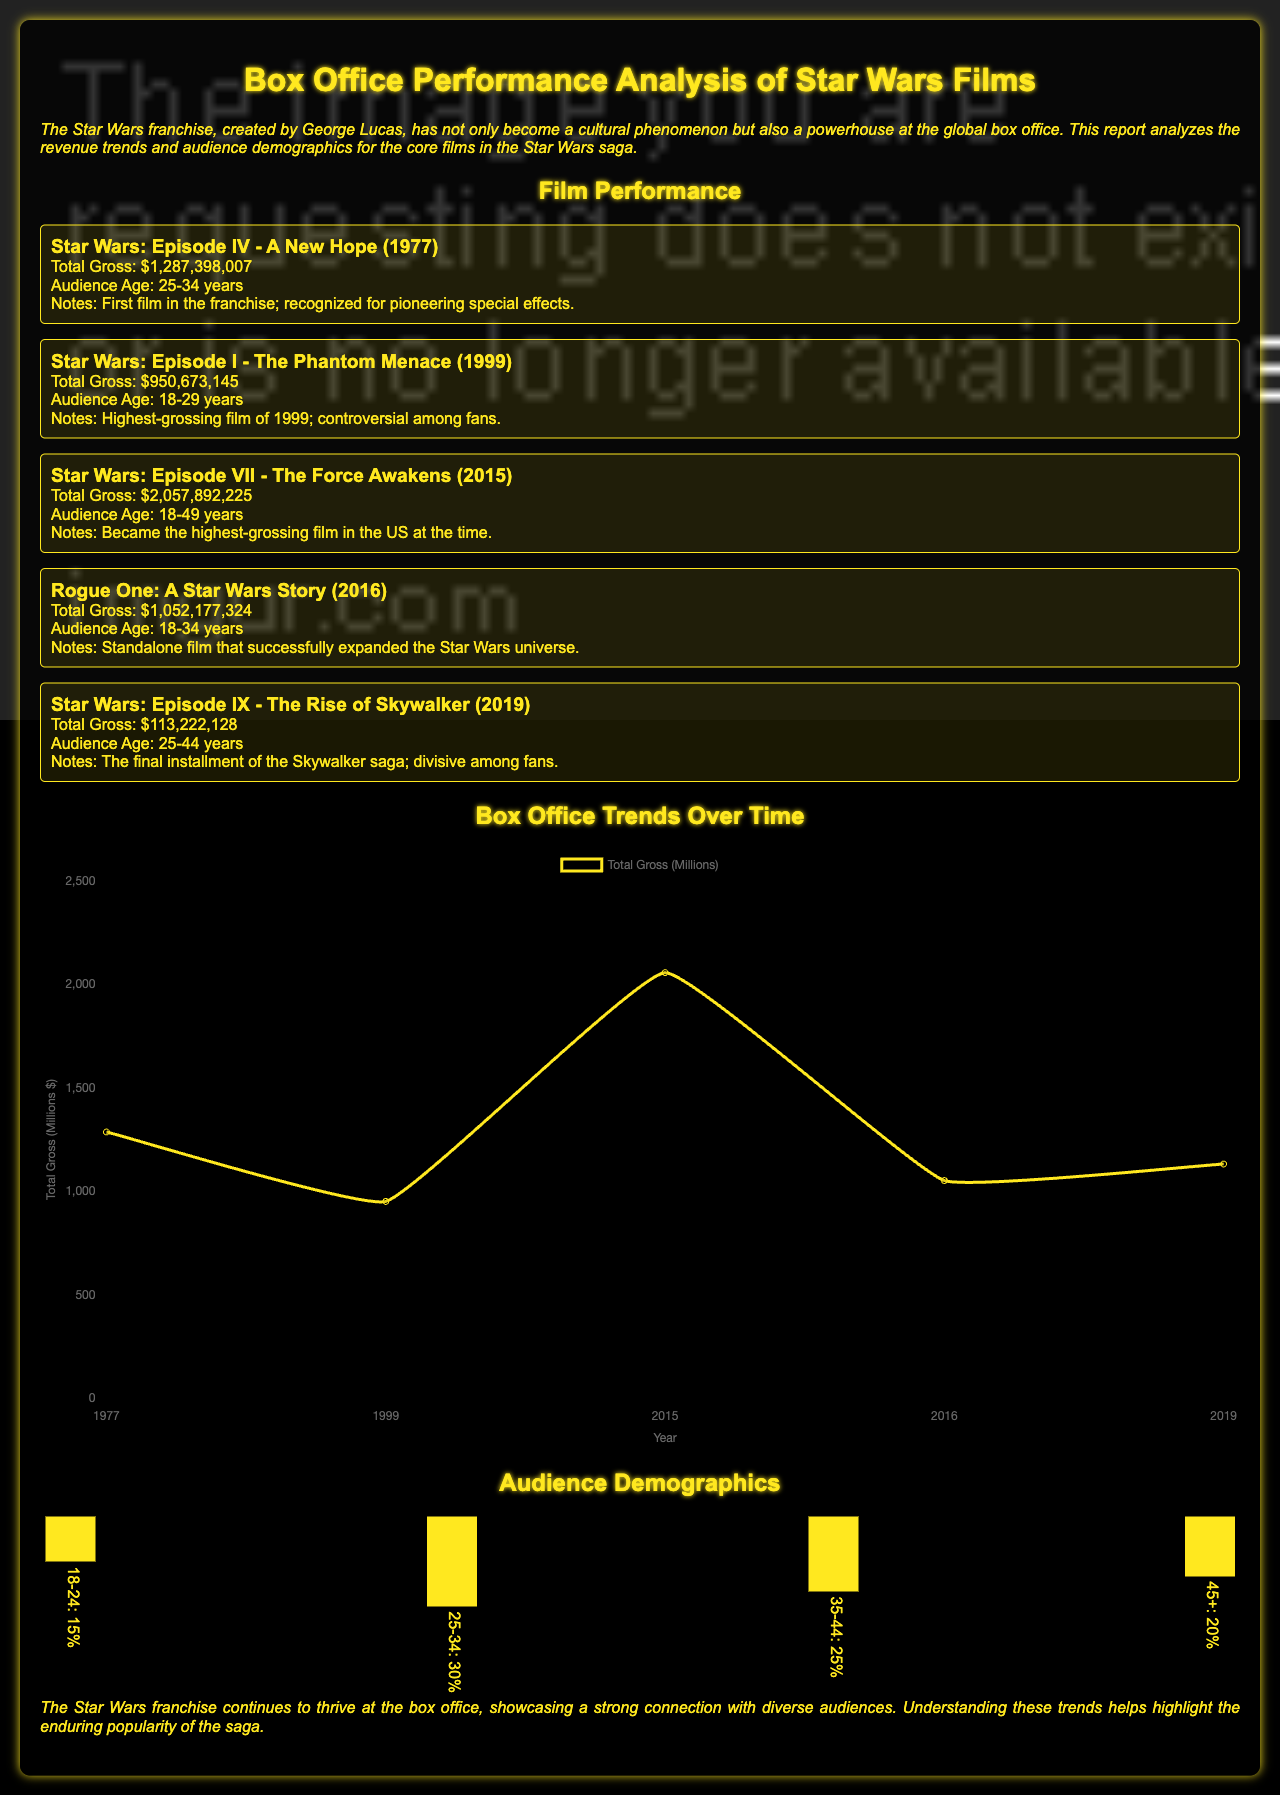What is the total gross of "Star Wars: Episode IV - A New Hope"? The total gross for "Star Wars: Episode IV - A New Hope" is listed in the document as $1,287,398,007.
Answer: $1,287,398,007 Which film was the highest-grossing in 1999? According to the notable notes for "Star Wars: Episode I - The Phantom Menace," it was the highest-grossing film of 1999.
Answer: Star Wars: Episode I - The Phantom Menace What audience age group does "Rogue One: A Star Wars Story" cater to? The audience age group for "Rogue One: A Star Wars Story" is mentioned as 18-34 years.
Answer: 18-34 years What is the total gross for "Star Wars: Episode VII - The Force Awakens"? For "Star Wars: Episode VII - The Force Awakens," the total gross is provided as $2,057,892,225.
Answer: $2,057,892,225 In what year was "Star Wars: Episode IX - The Rise of Skywalker" released? The release year for "Star Wars: Episode IX - The Rise of Skywalker" is mentioned as 2019 in the document.
Answer: 2019 What percentage of the audience is aged 25-34 years? The demographics section shows that 30% of the audience falls in the 25-34 years age group.
Answer: 30% Which film is noted for being recognized for pioneering special effects? "Star Wars: Episode IV - A New Hope" is noted for pioneering special effects in the document.
Answer: Star Wars: Episode IV - A New Hope What is the total gross of "Star Wars: Episode IX - The Rise of Skywalker"? The document states that the total gross for "Star Wars: Episode IX - The Rise of Skywalker" is $1,132,221,28.
Answer: $1,132,221,28 